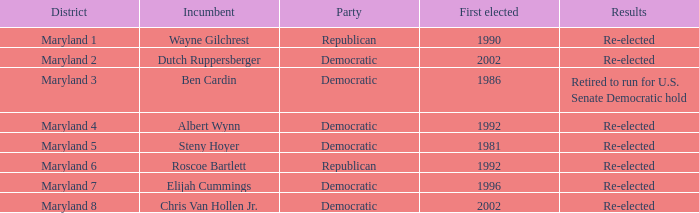What are the results of the incumbent who was first elected in 1996? Re-elected. 